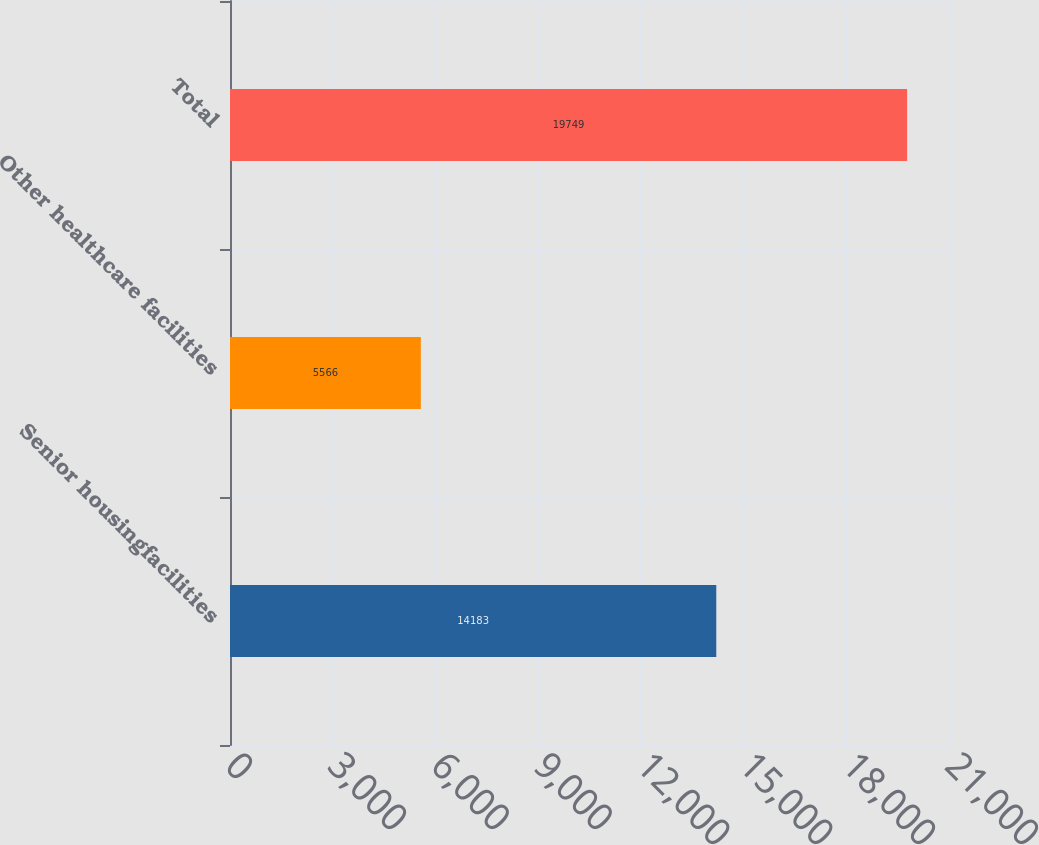<chart> <loc_0><loc_0><loc_500><loc_500><bar_chart><fcel>Senior housingfacilities<fcel>Other healthcare facilities<fcel>Total<nl><fcel>14183<fcel>5566<fcel>19749<nl></chart> 